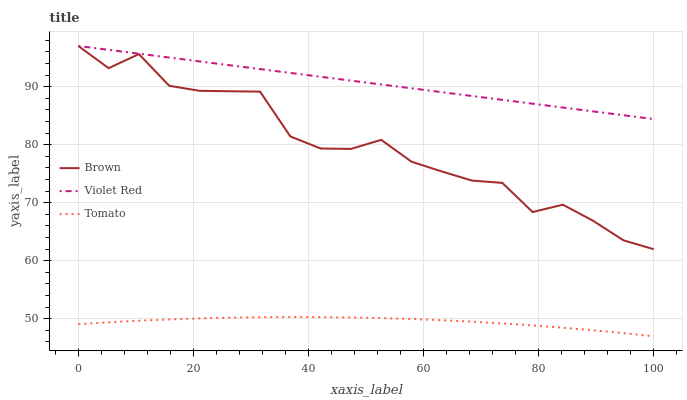Does Tomato have the minimum area under the curve?
Answer yes or no. Yes. Does Violet Red have the maximum area under the curve?
Answer yes or no. Yes. Does Brown have the minimum area under the curve?
Answer yes or no. No. Does Brown have the maximum area under the curve?
Answer yes or no. No. Is Violet Red the smoothest?
Answer yes or no. Yes. Is Brown the roughest?
Answer yes or no. Yes. Is Brown the smoothest?
Answer yes or no. No. Is Violet Red the roughest?
Answer yes or no. No. Does Tomato have the lowest value?
Answer yes or no. Yes. Does Brown have the lowest value?
Answer yes or no. No. Does Violet Red have the highest value?
Answer yes or no. Yes. Is Tomato less than Brown?
Answer yes or no. Yes. Is Brown greater than Tomato?
Answer yes or no. Yes. Does Violet Red intersect Brown?
Answer yes or no. Yes. Is Violet Red less than Brown?
Answer yes or no. No. Is Violet Red greater than Brown?
Answer yes or no. No. Does Tomato intersect Brown?
Answer yes or no. No. 